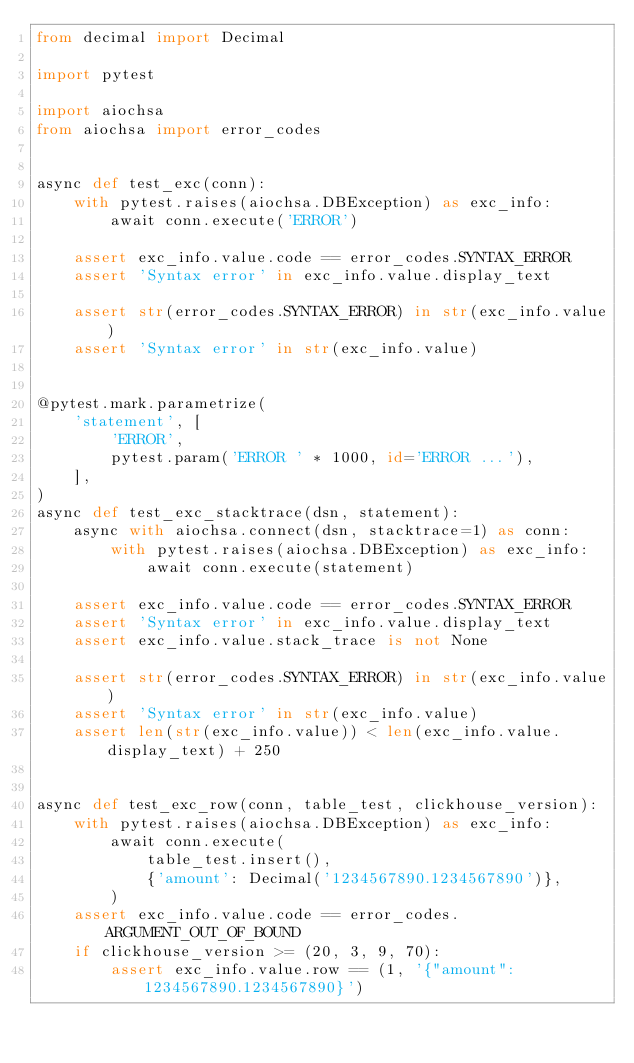Convert code to text. <code><loc_0><loc_0><loc_500><loc_500><_Python_>from decimal import Decimal

import pytest

import aiochsa
from aiochsa import error_codes


async def test_exc(conn):
    with pytest.raises(aiochsa.DBException) as exc_info:
        await conn.execute('ERROR')

    assert exc_info.value.code == error_codes.SYNTAX_ERROR
    assert 'Syntax error' in exc_info.value.display_text

    assert str(error_codes.SYNTAX_ERROR) in str(exc_info.value)
    assert 'Syntax error' in str(exc_info.value)


@pytest.mark.parametrize(
    'statement', [
        'ERROR',
        pytest.param('ERROR ' * 1000, id='ERROR ...'),
    ],
)
async def test_exc_stacktrace(dsn, statement):
    async with aiochsa.connect(dsn, stacktrace=1) as conn:
        with pytest.raises(aiochsa.DBException) as exc_info:
            await conn.execute(statement)

    assert exc_info.value.code == error_codes.SYNTAX_ERROR
    assert 'Syntax error' in exc_info.value.display_text
    assert exc_info.value.stack_trace is not None

    assert str(error_codes.SYNTAX_ERROR) in str(exc_info.value)
    assert 'Syntax error' in str(exc_info.value)
    assert len(str(exc_info.value)) < len(exc_info.value.display_text) + 250


async def test_exc_row(conn, table_test, clickhouse_version):
    with pytest.raises(aiochsa.DBException) as exc_info:
        await conn.execute(
            table_test.insert(),
            {'amount': Decimal('1234567890.1234567890')},
        )
    assert exc_info.value.code == error_codes.ARGUMENT_OUT_OF_BOUND
    if clickhouse_version >= (20, 3, 9, 70):
        assert exc_info.value.row == (1, '{"amount": 1234567890.1234567890}')
</code> 